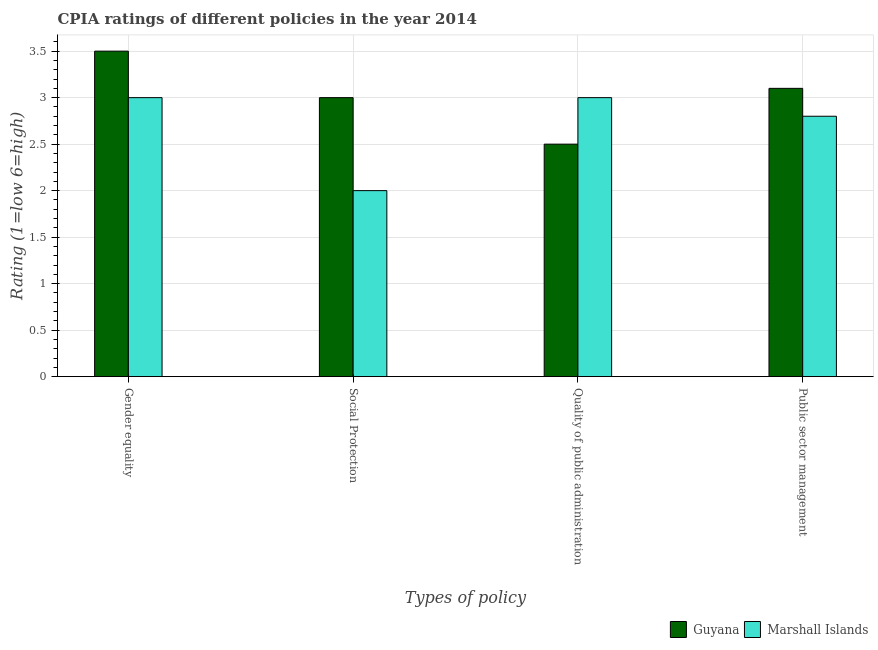How many different coloured bars are there?
Your answer should be compact. 2. Are the number of bars on each tick of the X-axis equal?
Make the answer very short. Yes. How many bars are there on the 4th tick from the left?
Offer a terse response. 2. What is the label of the 4th group of bars from the left?
Provide a short and direct response. Public sector management. What is the cpia rating of gender equality in Guyana?
Your response must be concise. 3.5. Across all countries, what is the maximum cpia rating of public sector management?
Provide a short and direct response. 3.1. In which country was the cpia rating of social protection maximum?
Offer a terse response. Guyana. In which country was the cpia rating of public sector management minimum?
Your answer should be compact. Marshall Islands. What is the total cpia rating of public sector management in the graph?
Offer a terse response. 5.9. What is the difference between the cpia rating of gender equality in Marshall Islands and that in Guyana?
Keep it short and to the point. -0.5. What is the difference between the cpia rating of public sector management in Guyana and the cpia rating of quality of public administration in Marshall Islands?
Make the answer very short. 0.1. In how many countries, is the cpia rating of social protection greater than 0.8 ?
Your answer should be compact. 2. What is the ratio of the cpia rating of quality of public administration in Guyana to that in Marshall Islands?
Make the answer very short. 0.83. Is the cpia rating of gender equality in Guyana less than that in Marshall Islands?
Your response must be concise. No. Is the difference between the cpia rating of social protection in Guyana and Marshall Islands greater than the difference between the cpia rating of public sector management in Guyana and Marshall Islands?
Make the answer very short. Yes. What is the difference between the highest and the lowest cpia rating of public sector management?
Keep it short and to the point. 0.3. Is the sum of the cpia rating of social protection in Guyana and Marshall Islands greater than the maximum cpia rating of quality of public administration across all countries?
Give a very brief answer. Yes. Is it the case that in every country, the sum of the cpia rating of gender equality and cpia rating of social protection is greater than the sum of cpia rating of quality of public administration and cpia rating of public sector management?
Your answer should be very brief. No. What does the 1st bar from the left in Quality of public administration represents?
Your answer should be very brief. Guyana. What does the 1st bar from the right in Social Protection represents?
Your response must be concise. Marshall Islands. Is it the case that in every country, the sum of the cpia rating of gender equality and cpia rating of social protection is greater than the cpia rating of quality of public administration?
Keep it short and to the point. Yes. Are all the bars in the graph horizontal?
Your response must be concise. No. How many countries are there in the graph?
Your answer should be compact. 2. What is the difference between two consecutive major ticks on the Y-axis?
Your answer should be very brief. 0.5. Does the graph contain any zero values?
Your answer should be very brief. No. Does the graph contain grids?
Provide a succinct answer. Yes. How many legend labels are there?
Offer a terse response. 2. How are the legend labels stacked?
Offer a very short reply. Horizontal. What is the title of the graph?
Ensure brevity in your answer.  CPIA ratings of different policies in the year 2014. Does "Other small states" appear as one of the legend labels in the graph?
Provide a short and direct response. No. What is the label or title of the X-axis?
Make the answer very short. Types of policy. What is the Rating (1=low 6=high) in Marshall Islands in Social Protection?
Your response must be concise. 2. What is the Rating (1=low 6=high) in Marshall Islands in Quality of public administration?
Provide a succinct answer. 3. What is the Rating (1=low 6=high) of Marshall Islands in Public sector management?
Your response must be concise. 2.8. Across all Types of policy, what is the maximum Rating (1=low 6=high) in Guyana?
Your response must be concise. 3.5. Across all Types of policy, what is the maximum Rating (1=low 6=high) of Marshall Islands?
Your answer should be very brief. 3. What is the total Rating (1=low 6=high) of Guyana in the graph?
Provide a succinct answer. 12.1. What is the total Rating (1=low 6=high) in Marshall Islands in the graph?
Ensure brevity in your answer.  10.8. What is the difference between the Rating (1=low 6=high) of Guyana in Gender equality and that in Social Protection?
Offer a very short reply. 0.5. What is the difference between the Rating (1=low 6=high) in Marshall Islands in Gender equality and that in Quality of public administration?
Your response must be concise. 0. What is the difference between the Rating (1=low 6=high) in Guyana in Gender equality and that in Public sector management?
Provide a short and direct response. 0.4. What is the difference between the Rating (1=low 6=high) in Marshall Islands in Social Protection and that in Quality of public administration?
Your response must be concise. -1. What is the difference between the Rating (1=low 6=high) of Guyana in Social Protection and that in Public sector management?
Make the answer very short. -0.1. What is the difference between the Rating (1=low 6=high) of Guyana in Gender equality and the Rating (1=low 6=high) of Marshall Islands in Quality of public administration?
Give a very brief answer. 0.5. What is the difference between the Rating (1=low 6=high) in Guyana in Social Protection and the Rating (1=low 6=high) in Marshall Islands in Quality of public administration?
Provide a succinct answer. 0. What is the difference between the Rating (1=low 6=high) in Guyana in Quality of public administration and the Rating (1=low 6=high) in Marshall Islands in Public sector management?
Offer a terse response. -0.3. What is the average Rating (1=low 6=high) of Guyana per Types of policy?
Keep it short and to the point. 3.02. What is the average Rating (1=low 6=high) of Marshall Islands per Types of policy?
Keep it short and to the point. 2.7. What is the difference between the Rating (1=low 6=high) in Guyana and Rating (1=low 6=high) in Marshall Islands in Gender equality?
Offer a very short reply. 0.5. What is the difference between the Rating (1=low 6=high) in Guyana and Rating (1=low 6=high) in Marshall Islands in Quality of public administration?
Offer a terse response. -0.5. What is the ratio of the Rating (1=low 6=high) of Marshall Islands in Gender equality to that in Social Protection?
Keep it short and to the point. 1.5. What is the ratio of the Rating (1=low 6=high) of Guyana in Gender equality to that in Quality of public administration?
Provide a short and direct response. 1.4. What is the ratio of the Rating (1=low 6=high) in Marshall Islands in Gender equality to that in Quality of public administration?
Your answer should be very brief. 1. What is the ratio of the Rating (1=low 6=high) in Guyana in Gender equality to that in Public sector management?
Your answer should be compact. 1.13. What is the ratio of the Rating (1=low 6=high) in Marshall Islands in Gender equality to that in Public sector management?
Make the answer very short. 1.07. What is the ratio of the Rating (1=low 6=high) of Guyana in Social Protection to that in Public sector management?
Your answer should be very brief. 0.97. What is the ratio of the Rating (1=low 6=high) of Marshall Islands in Social Protection to that in Public sector management?
Provide a short and direct response. 0.71. What is the ratio of the Rating (1=low 6=high) in Guyana in Quality of public administration to that in Public sector management?
Offer a terse response. 0.81. What is the ratio of the Rating (1=low 6=high) in Marshall Islands in Quality of public administration to that in Public sector management?
Your response must be concise. 1.07. What is the difference between the highest and the lowest Rating (1=low 6=high) in Marshall Islands?
Your response must be concise. 1. 